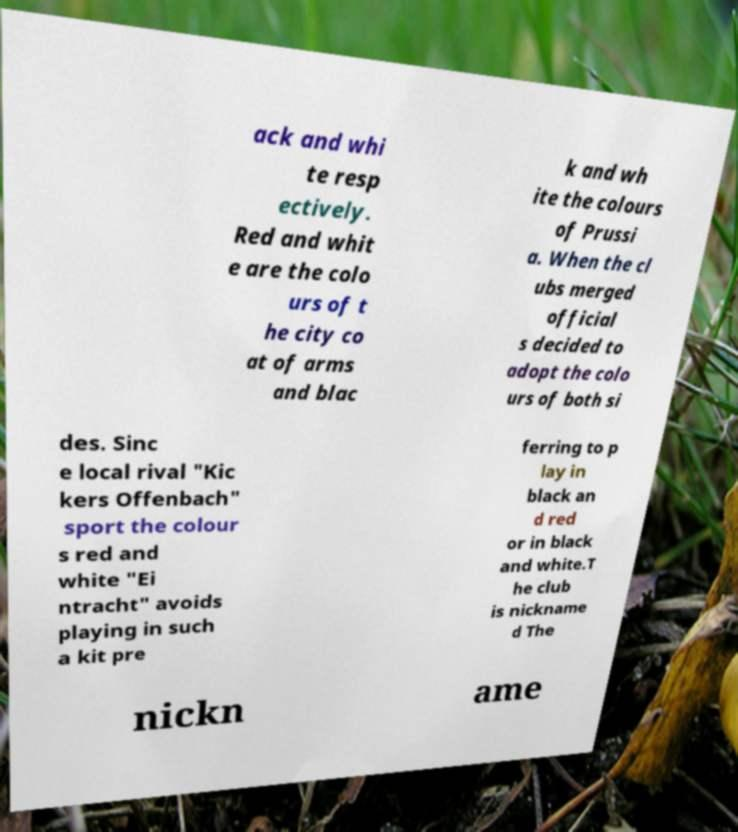Can you accurately transcribe the text from the provided image for me? ack and whi te resp ectively. Red and whit e are the colo urs of t he city co at of arms and blac k and wh ite the colours of Prussi a. When the cl ubs merged official s decided to adopt the colo urs of both si des. Sinc e local rival "Kic kers Offenbach" sport the colour s red and white "Ei ntracht" avoids playing in such a kit pre ferring to p lay in black an d red or in black and white.T he club is nickname d The nickn ame 